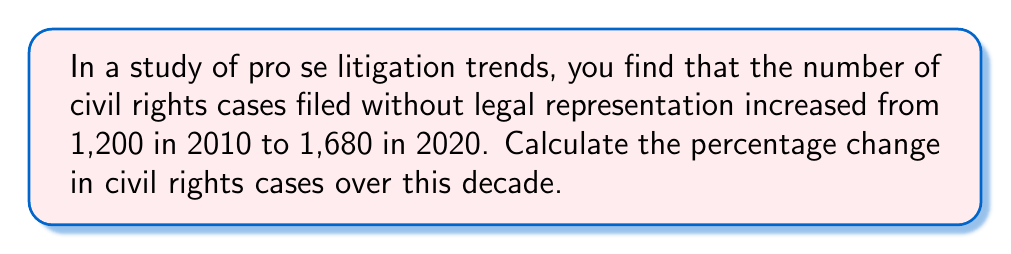Can you answer this question? To calculate the percentage change, we'll use the formula:

$$ \text{Percentage Change} = \frac{\text{New Value} - \text{Original Value}}{\text{Original Value}} \times 100\% $$

Let's plug in our values:
Original Value (2010): 1,200 cases
New Value (2020): 1,680 cases

$$ \text{Percentage Change} = \frac{1,680 - 1,200}{1,200} \times 100\% $$

$$ = \frac{480}{1,200} \times 100\% $$

$$ = 0.4 \times 100\% $$

$$ = 40\% $$

Therefore, the percentage change in civil rights cases filed without legal representation from 2010 to 2020 is a 40% increase.
Answer: 40% increase 